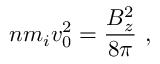<formula> <loc_0><loc_0><loc_500><loc_500>n m _ { i } v _ { 0 } ^ { 2 } = \frac { B _ { z } ^ { 2 } } { 8 \pi } \ ,</formula> 